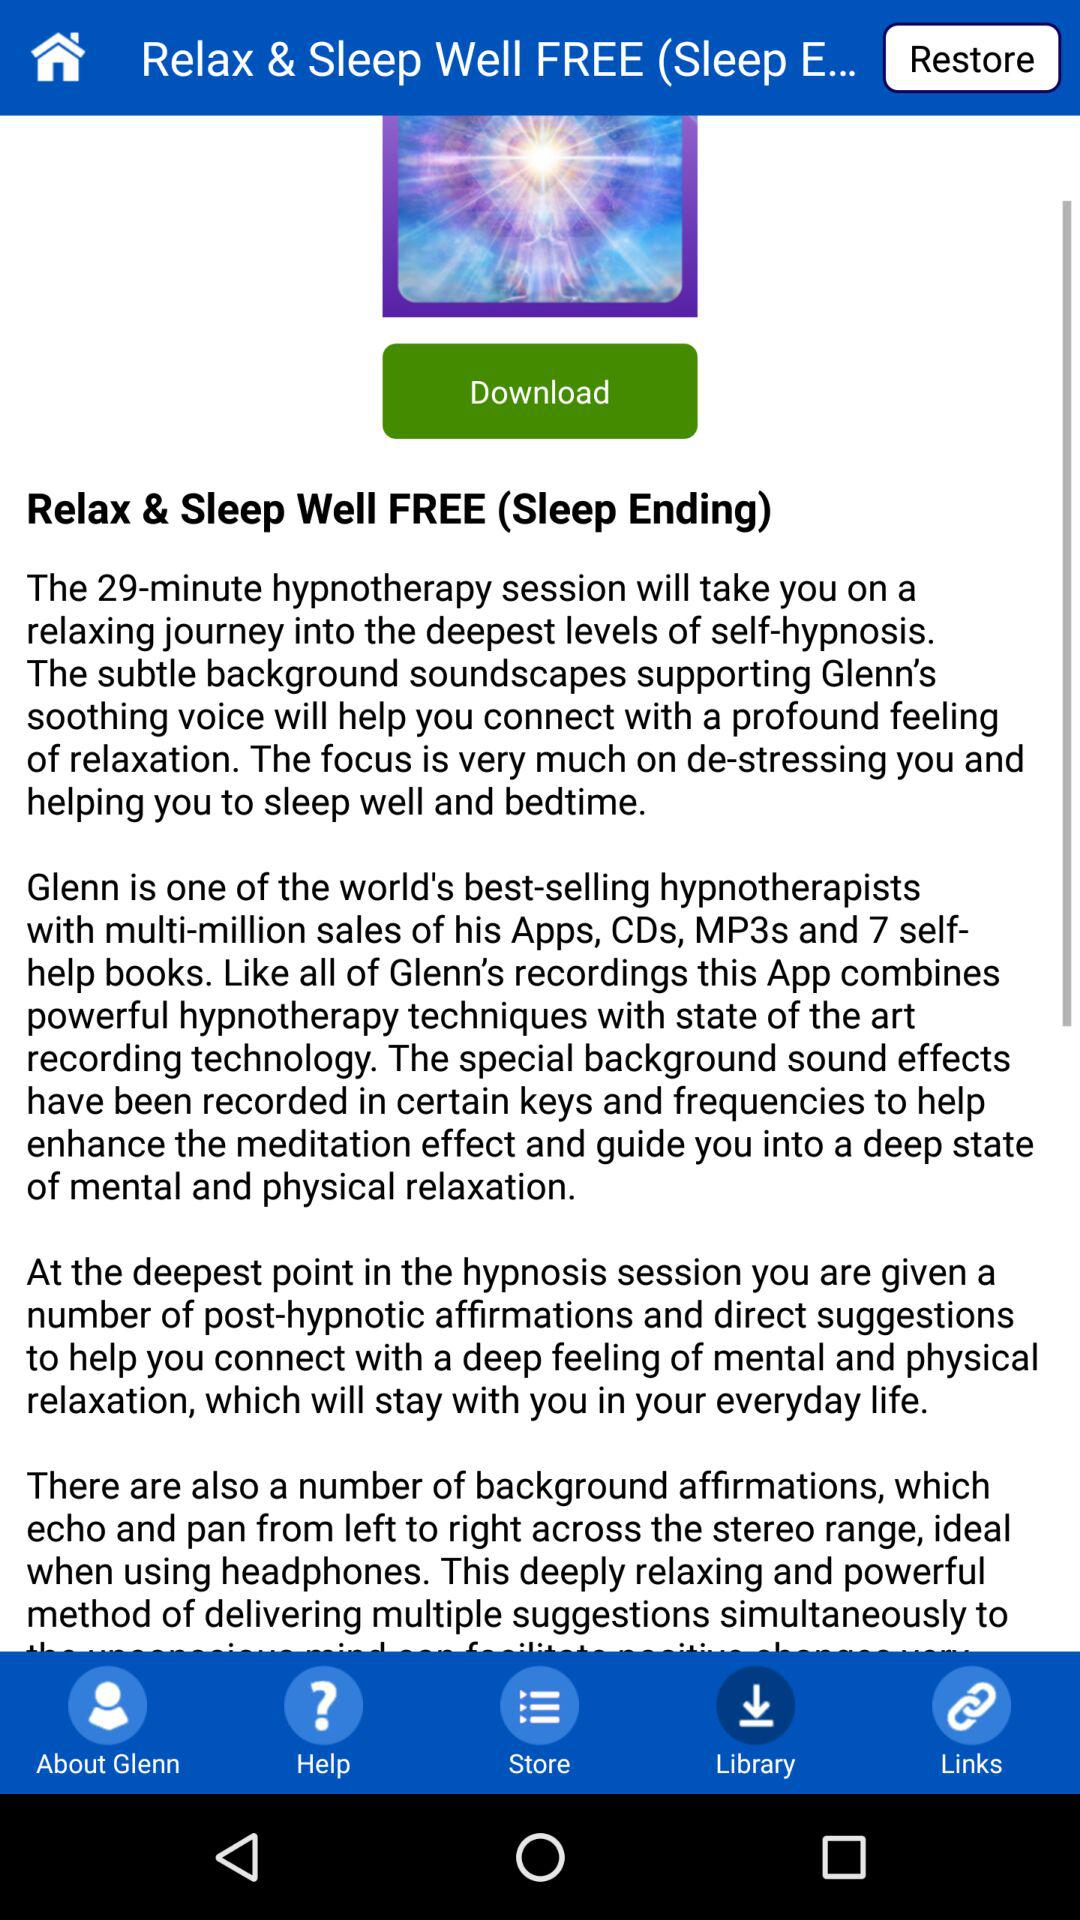What is the name of the shown application? The name of the shown application is "Relax & Sleep Well FREE". 